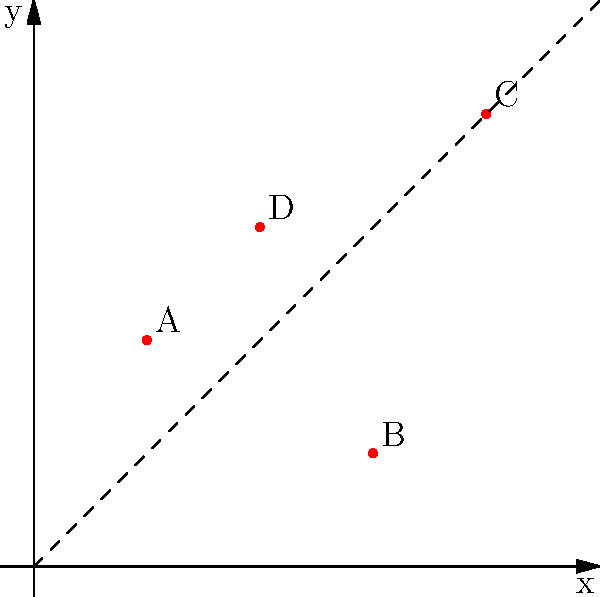In your first competitive game, you need to quickly identify enemy positions on a 2D map. The game uses a coordinate system where the x-axis represents horizontal position and the y-axis represents vertical position. Four enemy players (A, B, C, and D) are spotted on the map. Which enemy is positioned closest to the diagonal line $y = x$? To find the enemy closest to the line $y = x$, we need to:

1. Identify the coordinates of each enemy:
   A: (1, 2)
   B: (3, 1)
   C: (4, 4)
   D: (2, 3)

2. Calculate the distance of each point from the line $y = x$. The formula for this distance is:

   $d = \frac{|y - x|}{\sqrt{2}}$

3. Calculate the distance for each enemy:
   A: $d_A = \frac{|2 - 1|}{\sqrt{2}} = \frac{1}{\sqrt{2}} \approx 0.707$
   B: $d_B = \frac{|1 - 3|}{\sqrt{2}} = \frac{2}{\sqrt{2}} \approx 1.414$
   C: $d_C = \frac{|4 - 4|}{\sqrt{2}} = \frac{0}{\sqrt{2}} = 0$
   D: $d_D = \frac{|3 - 2|}{\sqrt{2}} = \frac{1}{\sqrt{2}} \approx 0.707$

4. Compare the distances:
   C has the smallest distance (0), so it's the closest to the line $y = x$.
Answer: C 